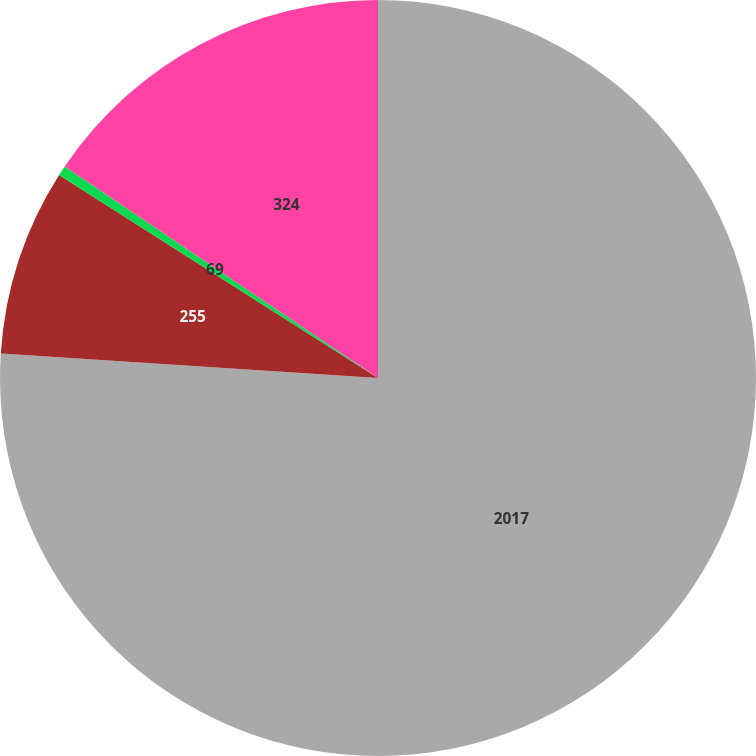Convert chart. <chart><loc_0><loc_0><loc_500><loc_500><pie_chart><fcel>2017<fcel>255<fcel>69<fcel>324<nl><fcel>76.04%<fcel>7.99%<fcel>0.43%<fcel>15.55%<nl></chart> 